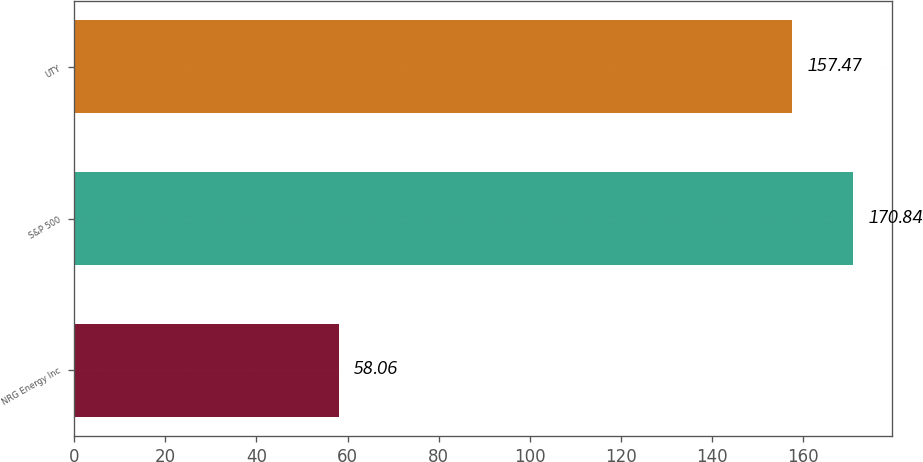Convert chart. <chart><loc_0><loc_0><loc_500><loc_500><bar_chart><fcel>NRG Energy Inc<fcel>S&P 500<fcel>UTY<nl><fcel>58.06<fcel>170.84<fcel>157.47<nl></chart> 